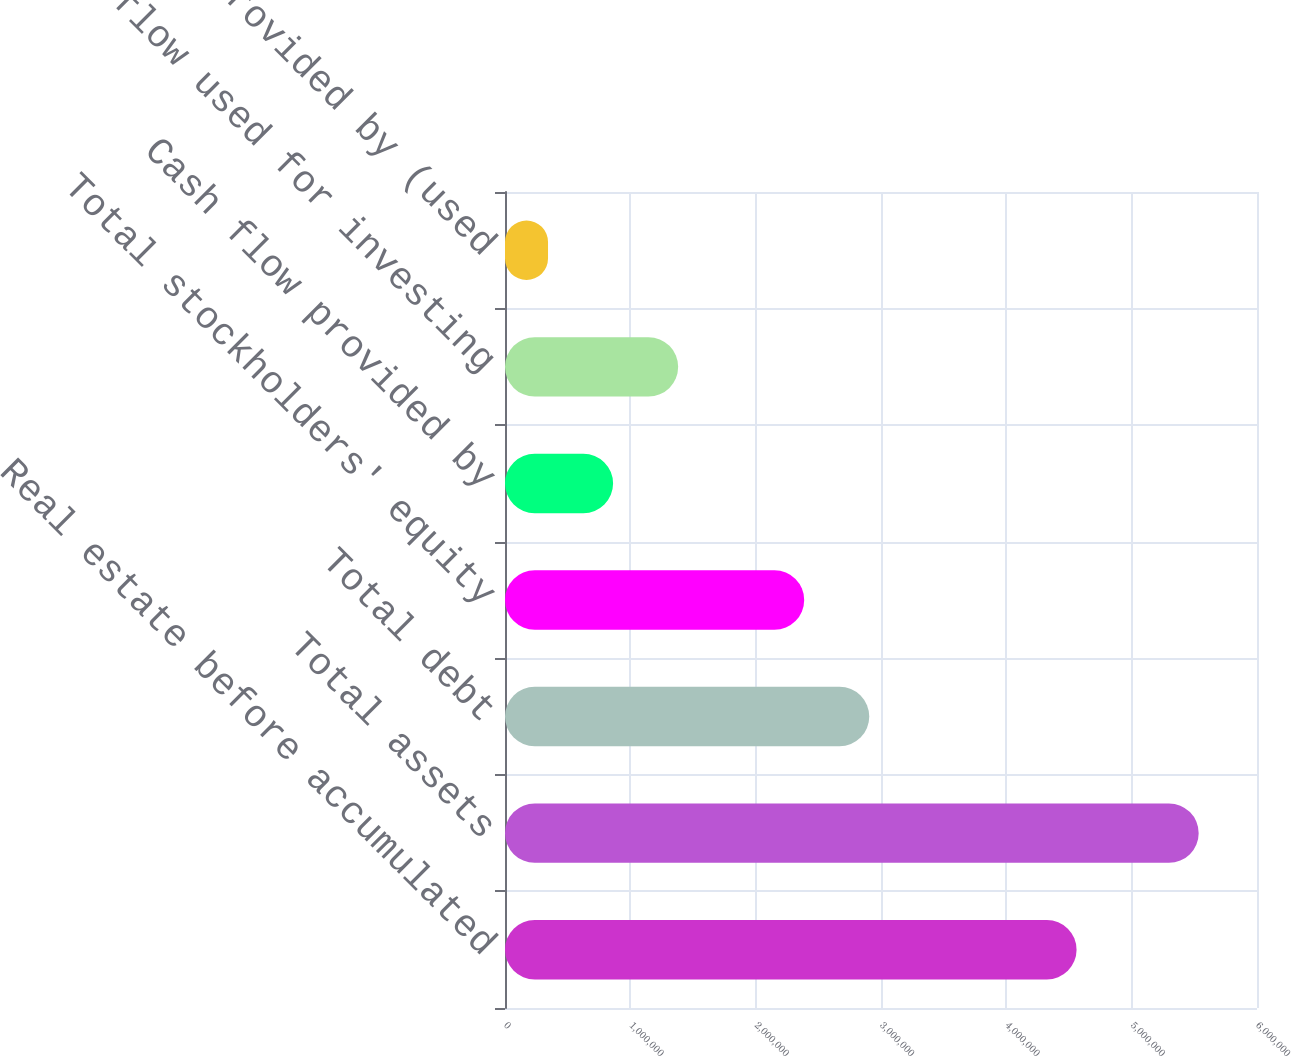<chart> <loc_0><loc_0><loc_500><loc_500><bar_chart><fcel>Real estate before accumulated<fcel>Total assets<fcel>Total debt<fcel>Total stockholders' equity<fcel>Cash flow provided by<fcel>Cash flow used for investing<fcel>Cash flow provided by (used<nl><fcel>4.56041e+06<fcel>5.53464e+06<fcel>2.90635e+06<fcel>2.38721e+06<fcel>862408<fcel>1.38154e+06<fcel>343271<nl></chart> 